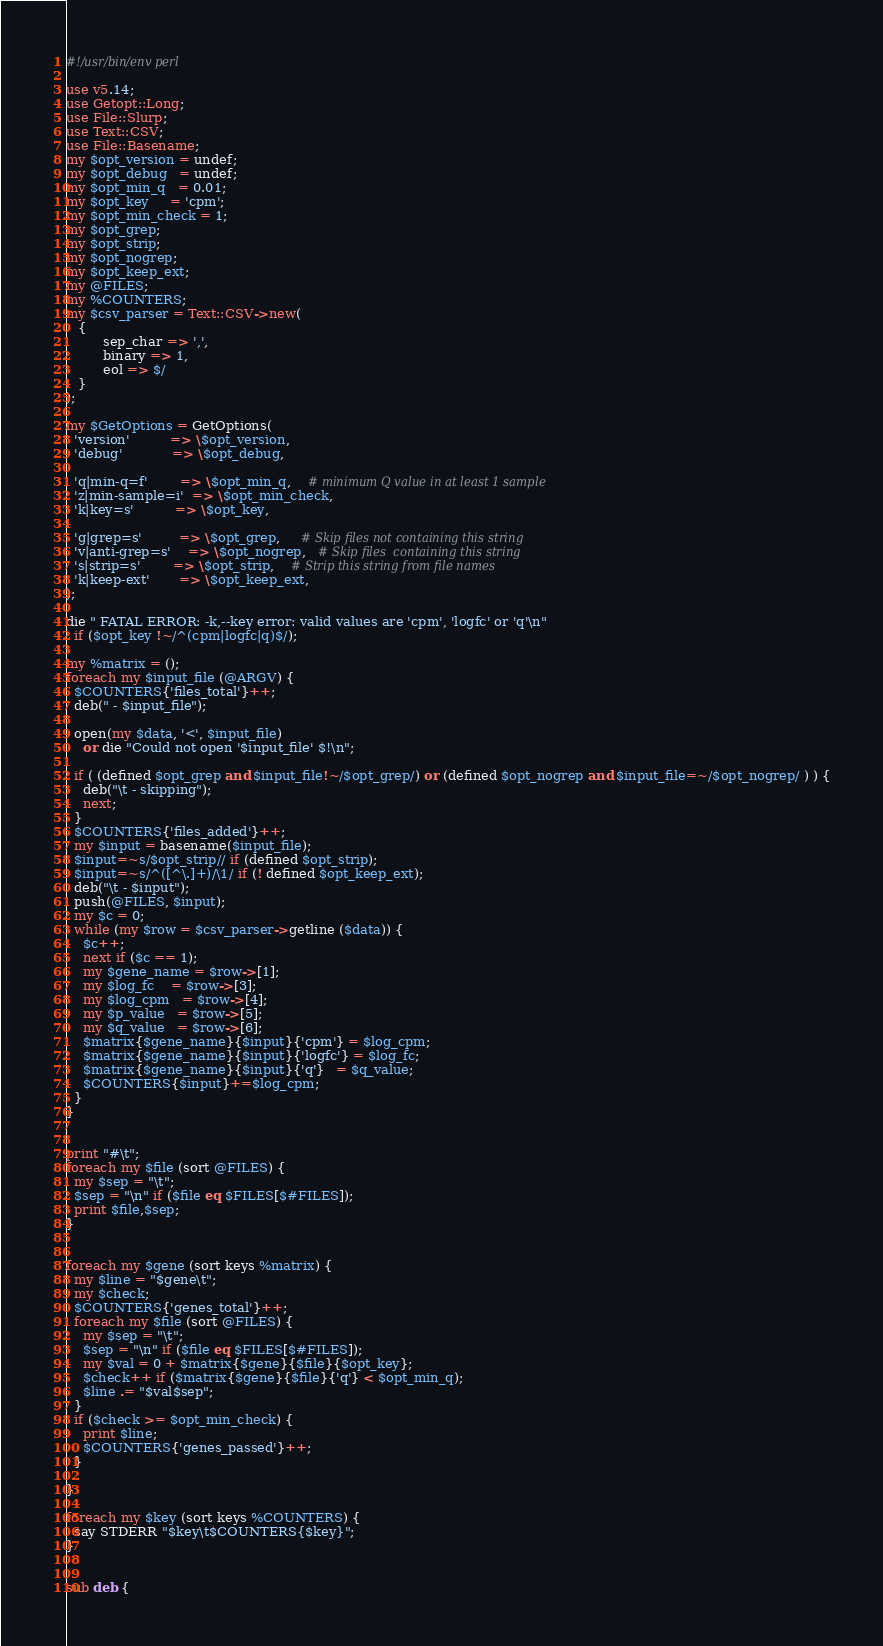Convert code to text. <code><loc_0><loc_0><loc_500><loc_500><_Perl_>#!/usr/bin/env perl

use v5.14;
use Getopt::Long;
use File::Slurp;
use Text::CSV;
use File::Basename;
my $opt_version = undef;
my $opt_debug   = undef;
my $opt_min_q   = 0.01;
my $opt_key     = 'cpm';
my $opt_min_check = 1;
my $opt_grep;
my $opt_strip;
my $opt_nogrep;
my $opt_keep_ext;
my @FILES;
my %COUNTERS;
my $csv_parser = Text::CSV->new(
   {
	     sep_char => ',',
	     binary => 1,
	     eol => $/
   }
);

my $GetOptions = GetOptions(
  'version'          => \$opt_version,
  'debug'            => \$opt_debug,

  'q|min-q=f'        => \$opt_min_q,    # minimum Q value in at least 1 sample
  'z|min-sample=i'  => \$opt_min_check,
  'k|key=s'          => \$opt_key,

  'g|grep=s'         => \$opt_grep,     # Skip files not containing this string
  'v|anti-grep=s'    => \$opt_nogrep,   # Skip files  containing this string
  's|strip=s'        => \$opt_strip,    # Strip this string from file names
  'k|keep-ext'       => \$opt_keep_ext,
);

die " FATAL ERROR: -k,--key error: valid values are 'cpm', 'logfc' or 'q'\n"
  if ($opt_key !~/^(cpm|logfc|q)$/);

my %matrix = ();
foreach my $input_file (@ARGV) {
  $COUNTERS{'files_total'}++;
  deb(" - $input_file");

  open(my $data, '<', $input_file)
    or die "Could not open '$input_file' $!\n";

  if ( (defined $opt_grep and $input_file!~/$opt_grep/) or (defined $opt_nogrep and $input_file=~/$opt_nogrep/ ) ) {
    deb("\t - skipping");
    next;
  }
  $COUNTERS{'files_added'}++;
  my $input = basename($input_file);
  $input=~s/$opt_strip// if (defined $opt_strip);
  $input=~s/^([^\.]+)/\1/ if (! defined $opt_keep_ext);
  deb("\t - $input");
  push(@FILES, $input);
  my $c = 0;
  while (my $row = $csv_parser->getline ($data)) {
    $c++;
    next if ($c == 1);
    my $gene_name = $row->[1];
    my $log_fc    = $row->[3];
    my $log_cpm   = $row->[4];
    my $p_value   = $row->[5];
    my $q_value   = $row->[6];
    $matrix{$gene_name}{$input}{'cpm'} = $log_cpm;
    $matrix{$gene_name}{$input}{'logfc'} = $log_fc;
    $matrix{$gene_name}{$input}{'q'}   = $q_value;
    $COUNTERS{$input}+=$log_cpm;
  }
}


print "#\t";
foreach my $file (sort @FILES) {
  my $sep = "\t";
  $sep = "\n" if ($file eq $FILES[$#FILES]);
  print $file,$sep;
}


foreach my $gene (sort keys %matrix) {
  my $line = "$gene\t";
  my $check;
  $COUNTERS{'genes_total'}++;
  foreach my $file (sort @FILES) {
    my $sep = "\t";
    $sep = "\n" if ($file eq $FILES[$#FILES]);
    my $val = 0 + $matrix{$gene}{$file}{$opt_key};
    $check++ if ($matrix{$gene}{$file}{'q'} < $opt_min_q);
    $line .= "$val$sep";
  }
  if ($check >= $opt_min_check) {
    print $line;
    $COUNTERS{'genes_passed'}++;
  }

}

foreach my $key (sort keys %COUNTERS) {
  say STDERR "$key\t$COUNTERS{$key}";
}


sub deb {</code> 